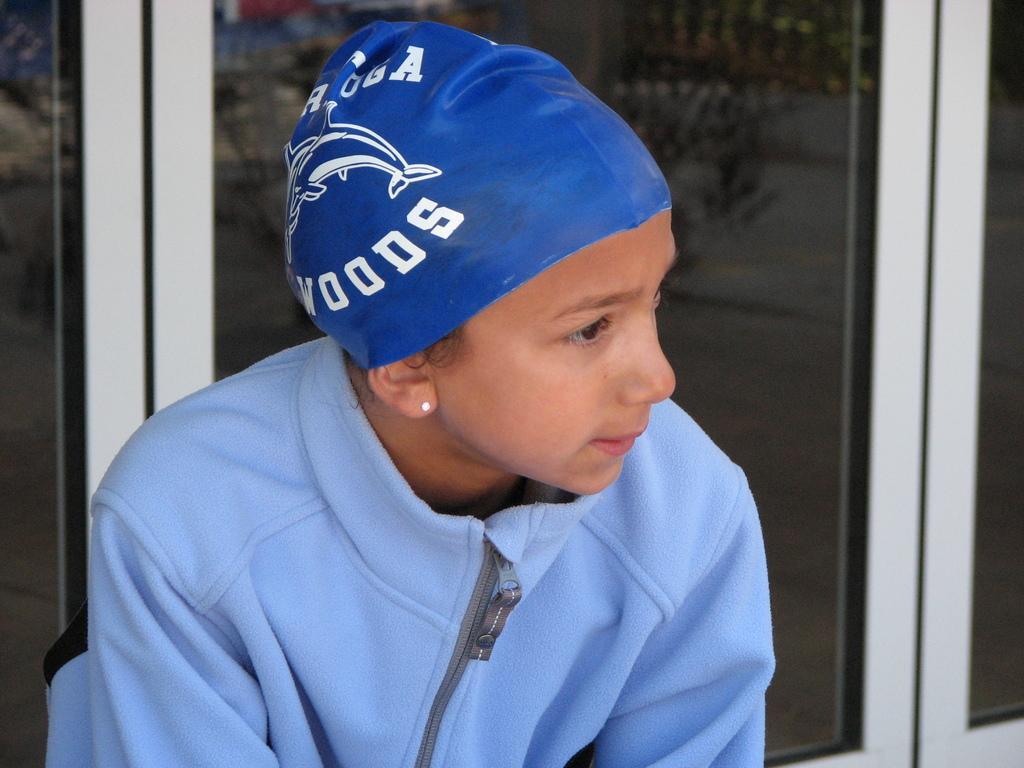Can you describe this image briefly? In front of the picture, we see a girl is wearing a blue jacket and blue cap. Behind her, we see the glass doors. 